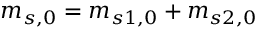<formula> <loc_0><loc_0><loc_500><loc_500>m _ { s , 0 } = m _ { s 1 , 0 } + m _ { s 2 , 0 }</formula> 